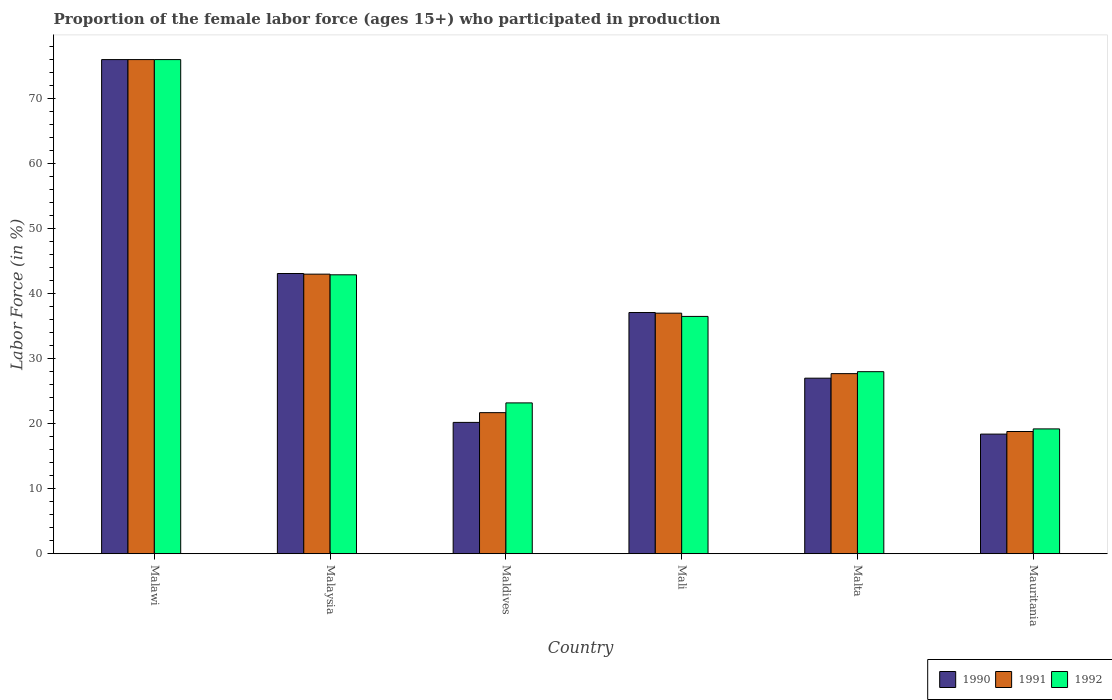How many different coloured bars are there?
Your response must be concise. 3. Are the number of bars per tick equal to the number of legend labels?
Give a very brief answer. Yes. Are the number of bars on each tick of the X-axis equal?
Your answer should be compact. Yes. How many bars are there on the 4th tick from the left?
Offer a terse response. 3. How many bars are there on the 3rd tick from the right?
Provide a succinct answer. 3. What is the label of the 6th group of bars from the left?
Ensure brevity in your answer.  Mauritania. What is the proportion of the female labor force who participated in production in 1992 in Malaysia?
Your response must be concise. 42.9. Across all countries, what is the minimum proportion of the female labor force who participated in production in 1991?
Your answer should be compact. 18.8. In which country was the proportion of the female labor force who participated in production in 1990 maximum?
Your answer should be compact. Malawi. In which country was the proportion of the female labor force who participated in production in 1991 minimum?
Give a very brief answer. Mauritania. What is the total proportion of the female labor force who participated in production in 1992 in the graph?
Give a very brief answer. 225.8. What is the difference between the proportion of the female labor force who participated in production in 1992 in Malawi and that in Mauritania?
Your answer should be very brief. 56.8. What is the difference between the proportion of the female labor force who participated in production in 1991 in Mali and the proportion of the female labor force who participated in production in 1992 in Malta?
Offer a very short reply. 9. What is the average proportion of the female labor force who participated in production in 1992 per country?
Offer a very short reply. 37.63. What is the difference between the proportion of the female labor force who participated in production of/in 1991 and proportion of the female labor force who participated in production of/in 1990 in Malaysia?
Your answer should be very brief. -0.1. In how many countries, is the proportion of the female labor force who participated in production in 1992 greater than 20 %?
Provide a succinct answer. 5. What is the ratio of the proportion of the female labor force who participated in production in 1991 in Mali to that in Malta?
Give a very brief answer. 1.34. Is the proportion of the female labor force who participated in production in 1991 in Malawi less than that in Malaysia?
Your answer should be very brief. No. Is the difference between the proportion of the female labor force who participated in production in 1991 in Malta and Mauritania greater than the difference between the proportion of the female labor force who participated in production in 1990 in Malta and Mauritania?
Offer a terse response. Yes. What is the difference between the highest and the second highest proportion of the female labor force who participated in production in 1992?
Your answer should be compact. -33.1. What is the difference between the highest and the lowest proportion of the female labor force who participated in production in 1992?
Provide a succinct answer. 56.8. Is the sum of the proportion of the female labor force who participated in production in 1991 in Malawi and Mali greater than the maximum proportion of the female labor force who participated in production in 1990 across all countries?
Make the answer very short. Yes. What does the 1st bar from the right in Malawi represents?
Keep it short and to the point. 1992. Are all the bars in the graph horizontal?
Your response must be concise. No. How many countries are there in the graph?
Provide a short and direct response. 6. Does the graph contain grids?
Your answer should be very brief. No. How are the legend labels stacked?
Offer a terse response. Horizontal. What is the title of the graph?
Your response must be concise. Proportion of the female labor force (ages 15+) who participated in production. Does "1999" appear as one of the legend labels in the graph?
Your response must be concise. No. What is the label or title of the Y-axis?
Provide a succinct answer. Labor Force (in %). What is the Labor Force (in %) of 1990 in Malawi?
Offer a very short reply. 76. What is the Labor Force (in %) in 1990 in Malaysia?
Provide a short and direct response. 43.1. What is the Labor Force (in %) of 1992 in Malaysia?
Your answer should be compact. 42.9. What is the Labor Force (in %) in 1990 in Maldives?
Keep it short and to the point. 20.2. What is the Labor Force (in %) of 1991 in Maldives?
Make the answer very short. 21.7. What is the Labor Force (in %) of 1992 in Maldives?
Give a very brief answer. 23.2. What is the Labor Force (in %) in 1990 in Mali?
Give a very brief answer. 37.1. What is the Labor Force (in %) of 1991 in Mali?
Make the answer very short. 37. What is the Labor Force (in %) of 1992 in Mali?
Offer a very short reply. 36.5. What is the Labor Force (in %) in 1990 in Malta?
Your answer should be compact. 27. What is the Labor Force (in %) in 1991 in Malta?
Ensure brevity in your answer.  27.7. What is the Labor Force (in %) in 1992 in Malta?
Offer a terse response. 28. What is the Labor Force (in %) of 1990 in Mauritania?
Keep it short and to the point. 18.4. What is the Labor Force (in %) in 1991 in Mauritania?
Your answer should be compact. 18.8. What is the Labor Force (in %) in 1992 in Mauritania?
Provide a short and direct response. 19.2. Across all countries, what is the maximum Labor Force (in %) of 1991?
Make the answer very short. 76. Across all countries, what is the maximum Labor Force (in %) in 1992?
Give a very brief answer. 76. Across all countries, what is the minimum Labor Force (in %) in 1990?
Keep it short and to the point. 18.4. Across all countries, what is the minimum Labor Force (in %) in 1991?
Offer a very short reply. 18.8. Across all countries, what is the minimum Labor Force (in %) in 1992?
Make the answer very short. 19.2. What is the total Labor Force (in %) of 1990 in the graph?
Make the answer very short. 221.8. What is the total Labor Force (in %) of 1991 in the graph?
Provide a succinct answer. 224.2. What is the total Labor Force (in %) in 1992 in the graph?
Ensure brevity in your answer.  225.8. What is the difference between the Labor Force (in %) in 1990 in Malawi and that in Malaysia?
Offer a very short reply. 32.9. What is the difference between the Labor Force (in %) in 1991 in Malawi and that in Malaysia?
Provide a short and direct response. 33. What is the difference between the Labor Force (in %) of 1992 in Malawi and that in Malaysia?
Offer a terse response. 33.1. What is the difference between the Labor Force (in %) in 1990 in Malawi and that in Maldives?
Provide a succinct answer. 55.8. What is the difference between the Labor Force (in %) of 1991 in Malawi and that in Maldives?
Keep it short and to the point. 54.3. What is the difference between the Labor Force (in %) of 1992 in Malawi and that in Maldives?
Provide a short and direct response. 52.8. What is the difference between the Labor Force (in %) in 1990 in Malawi and that in Mali?
Your answer should be compact. 38.9. What is the difference between the Labor Force (in %) of 1991 in Malawi and that in Mali?
Give a very brief answer. 39. What is the difference between the Labor Force (in %) of 1992 in Malawi and that in Mali?
Your response must be concise. 39.5. What is the difference between the Labor Force (in %) in 1990 in Malawi and that in Malta?
Provide a short and direct response. 49. What is the difference between the Labor Force (in %) in 1991 in Malawi and that in Malta?
Give a very brief answer. 48.3. What is the difference between the Labor Force (in %) in 1990 in Malawi and that in Mauritania?
Give a very brief answer. 57.6. What is the difference between the Labor Force (in %) of 1991 in Malawi and that in Mauritania?
Keep it short and to the point. 57.2. What is the difference between the Labor Force (in %) of 1992 in Malawi and that in Mauritania?
Offer a very short reply. 56.8. What is the difference between the Labor Force (in %) in 1990 in Malaysia and that in Maldives?
Offer a very short reply. 22.9. What is the difference between the Labor Force (in %) in 1991 in Malaysia and that in Maldives?
Give a very brief answer. 21.3. What is the difference between the Labor Force (in %) of 1992 in Malaysia and that in Maldives?
Give a very brief answer. 19.7. What is the difference between the Labor Force (in %) of 1990 in Malaysia and that in Malta?
Your response must be concise. 16.1. What is the difference between the Labor Force (in %) in 1991 in Malaysia and that in Malta?
Provide a short and direct response. 15.3. What is the difference between the Labor Force (in %) of 1992 in Malaysia and that in Malta?
Give a very brief answer. 14.9. What is the difference between the Labor Force (in %) in 1990 in Malaysia and that in Mauritania?
Your answer should be very brief. 24.7. What is the difference between the Labor Force (in %) in 1991 in Malaysia and that in Mauritania?
Your response must be concise. 24.2. What is the difference between the Labor Force (in %) of 1992 in Malaysia and that in Mauritania?
Provide a succinct answer. 23.7. What is the difference between the Labor Force (in %) of 1990 in Maldives and that in Mali?
Provide a succinct answer. -16.9. What is the difference between the Labor Force (in %) of 1991 in Maldives and that in Mali?
Offer a terse response. -15.3. What is the difference between the Labor Force (in %) of 1990 in Maldives and that in Malta?
Keep it short and to the point. -6.8. What is the difference between the Labor Force (in %) in 1990 in Mali and that in Malta?
Ensure brevity in your answer.  10.1. What is the difference between the Labor Force (in %) of 1990 in Malta and that in Mauritania?
Your response must be concise. 8.6. What is the difference between the Labor Force (in %) of 1990 in Malawi and the Labor Force (in %) of 1991 in Malaysia?
Offer a very short reply. 33. What is the difference between the Labor Force (in %) of 1990 in Malawi and the Labor Force (in %) of 1992 in Malaysia?
Your answer should be compact. 33.1. What is the difference between the Labor Force (in %) in 1991 in Malawi and the Labor Force (in %) in 1992 in Malaysia?
Provide a succinct answer. 33.1. What is the difference between the Labor Force (in %) of 1990 in Malawi and the Labor Force (in %) of 1991 in Maldives?
Give a very brief answer. 54.3. What is the difference between the Labor Force (in %) in 1990 in Malawi and the Labor Force (in %) in 1992 in Maldives?
Provide a succinct answer. 52.8. What is the difference between the Labor Force (in %) of 1991 in Malawi and the Labor Force (in %) of 1992 in Maldives?
Ensure brevity in your answer.  52.8. What is the difference between the Labor Force (in %) in 1990 in Malawi and the Labor Force (in %) in 1992 in Mali?
Provide a short and direct response. 39.5. What is the difference between the Labor Force (in %) of 1991 in Malawi and the Labor Force (in %) of 1992 in Mali?
Your answer should be very brief. 39.5. What is the difference between the Labor Force (in %) of 1990 in Malawi and the Labor Force (in %) of 1991 in Malta?
Provide a short and direct response. 48.3. What is the difference between the Labor Force (in %) in 1991 in Malawi and the Labor Force (in %) in 1992 in Malta?
Your answer should be very brief. 48. What is the difference between the Labor Force (in %) of 1990 in Malawi and the Labor Force (in %) of 1991 in Mauritania?
Provide a succinct answer. 57.2. What is the difference between the Labor Force (in %) in 1990 in Malawi and the Labor Force (in %) in 1992 in Mauritania?
Your answer should be compact. 56.8. What is the difference between the Labor Force (in %) of 1991 in Malawi and the Labor Force (in %) of 1992 in Mauritania?
Provide a short and direct response. 56.8. What is the difference between the Labor Force (in %) in 1990 in Malaysia and the Labor Force (in %) in 1991 in Maldives?
Ensure brevity in your answer.  21.4. What is the difference between the Labor Force (in %) in 1991 in Malaysia and the Labor Force (in %) in 1992 in Maldives?
Offer a very short reply. 19.8. What is the difference between the Labor Force (in %) in 1990 in Malaysia and the Labor Force (in %) in 1991 in Mali?
Provide a short and direct response. 6.1. What is the difference between the Labor Force (in %) of 1990 in Malaysia and the Labor Force (in %) of 1992 in Mali?
Keep it short and to the point. 6.6. What is the difference between the Labor Force (in %) of 1990 in Malaysia and the Labor Force (in %) of 1991 in Malta?
Ensure brevity in your answer.  15.4. What is the difference between the Labor Force (in %) in 1990 in Malaysia and the Labor Force (in %) in 1992 in Malta?
Offer a very short reply. 15.1. What is the difference between the Labor Force (in %) of 1990 in Malaysia and the Labor Force (in %) of 1991 in Mauritania?
Make the answer very short. 24.3. What is the difference between the Labor Force (in %) in 1990 in Malaysia and the Labor Force (in %) in 1992 in Mauritania?
Your answer should be compact. 23.9. What is the difference between the Labor Force (in %) in 1991 in Malaysia and the Labor Force (in %) in 1992 in Mauritania?
Offer a terse response. 23.8. What is the difference between the Labor Force (in %) of 1990 in Maldives and the Labor Force (in %) of 1991 in Mali?
Provide a succinct answer. -16.8. What is the difference between the Labor Force (in %) in 1990 in Maldives and the Labor Force (in %) in 1992 in Mali?
Your answer should be very brief. -16.3. What is the difference between the Labor Force (in %) of 1991 in Maldives and the Labor Force (in %) of 1992 in Mali?
Provide a short and direct response. -14.8. What is the difference between the Labor Force (in %) in 1991 in Maldives and the Labor Force (in %) in 1992 in Malta?
Offer a terse response. -6.3. What is the difference between the Labor Force (in %) in 1990 in Maldives and the Labor Force (in %) in 1991 in Mauritania?
Keep it short and to the point. 1.4. What is the difference between the Labor Force (in %) of 1990 in Maldives and the Labor Force (in %) of 1992 in Mauritania?
Give a very brief answer. 1. What is the difference between the Labor Force (in %) in 1990 in Mali and the Labor Force (in %) in 1991 in Malta?
Your response must be concise. 9.4. What is the difference between the Labor Force (in %) of 1991 in Mali and the Labor Force (in %) of 1992 in Malta?
Offer a very short reply. 9. What is the difference between the Labor Force (in %) of 1990 in Mali and the Labor Force (in %) of 1991 in Mauritania?
Give a very brief answer. 18.3. What is the difference between the Labor Force (in %) in 1990 in Mali and the Labor Force (in %) in 1992 in Mauritania?
Provide a succinct answer. 17.9. What is the average Labor Force (in %) in 1990 per country?
Ensure brevity in your answer.  36.97. What is the average Labor Force (in %) of 1991 per country?
Ensure brevity in your answer.  37.37. What is the average Labor Force (in %) in 1992 per country?
Offer a terse response. 37.63. What is the difference between the Labor Force (in %) of 1990 and Labor Force (in %) of 1991 in Malawi?
Make the answer very short. 0. What is the difference between the Labor Force (in %) of 1990 and Labor Force (in %) of 1992 in Malawi?
Offer a terse response. 0. What is the difference between the Labor Force (in %) in 1991 and Labor Force (in %) in 1992 in Malawi?
Your response must be concise. 0. What is the difference between the Labor Force (in %) in 1990 and Labor Force (in %) in 1991 in Malaysia?
Your response must be concise. 0.1. What is the difference between the Labor Force (in %) of 1990 and Labor Force (in %) of 1992 in Malaysia?
Keep it short and to the point. 0.2. What is the difference between the Labor Force (in %) in 1990 and Labor Force (in %) in 1992 in Maldives?
Your answer should be very brief. -3. What is the difference between the Labor Force (in %) of 1990 and Labor Force (in %) of 1992 in Mali?
Make the answer very short. 0.6. What is the difference between the Labor Force (in %) of 1990 and Labor Force (in %) of 1991 in Malta?
Provide a succinct answer. -0.7. What is the difference between the Labor Force (in %) in 1990 and Labor Force (in %) in 1992 in Malta?
Your answer should be very brief. -1. What is the difference between the Labor Force (in %) in 1991 and Labor Force (in %) in 1992 in Malta?
Your response must be concise. -0.3. What is the difference between the Labor Force (in %) in 1990 and Labor Force (in %) in 1991 in Mauritania?
Give a very brief answer. -0.4. What is the difference between the Labor Force (in %) in 1991 and Labor Force (in %) in 1992 in Mauritania?
Offer a terse response. -0.4. What is the ratio of the Labor Force (in %) of 1990 in Malawi to that in Malaysia?
Your response must be concise. 1.76. What is the ratio of the Labor Force (in %) in 1991 in Malawi to that in Malaysia?
Ensure brevity in your answer.  1.77. What is the ratio of the Labor Force (in %) in 1992 in Malawi to that in Malaysia?
Ensure brevity in your answer.  1.77. What is the ratio of the Labor Force (in %) in 1990 in Malawi to that in Maldives?
Make the answer very short. 3.76. What is the ratio of the Labor Force (in %) in 1991 in Malawi to that in Maldives?
Your response must be concise. 3.5. What is the ratio of the Labor Force (in %) of 1992 in Malawi to that in Maldives?
Provide a succinct answer. 3.28. What is the ratio of the Labor Force (in %) in 1990 in Malawi to that in Mali?
Ensure brevity in your answer.  2.05. What is the ratio of the Labor Force (in %) of 1991 in Malawi to that in Mali?
Provide a succinct answer. 2.05. What is the ratio of the Labor Force (in %) in 1992 in Malawi to that in Mali?
Ensure brevity in your answer.  2.08. What is the ratio of the Labor Force (in %) in 1990 in Malawi to that in Malta?
Ensure brevity in your answer.  2.81. What is the ratio of the Labor Force (in %) in 1991 in Malawi to that in Malta?
Ensure brevity in your answer.  2.74. What is the ratio of the Labor Force (in %) of 1992 in Malawi to that in Malta?
Ensure brevity in your answer.  2.71. What is the ratio of the Labor Force (in %) of 1990 in Malawi to that in Mauritania?
Offer a very short reply. 4.13. What is the ratio of the Labor Force (in %) in 1991 in Malawi to that in Mauritania?
Keep it short and to the point. 4.04. What is the ratio of the Labor Force (in %) in 1992 in Malawi to that in Mauritania?
Your answer should be very brief. 3.96. What is the ratio of the Labor Force (in %) in 1990 in Malaysia to that in Maldives?
Offer a terse response. 2.13. What is the ratio of the Labor Force (in %) of 1991 in Malaysia to that in Maldives?
Ensure brevity in your answer.  1.98. What is the ratio of the Labor Force (in %) in 1992 in Malaysia to that in Maldives?
Make the answer very short. 1.85. What is the ratio of the Labor Force (in %) of 1990 in Malaysia to that in Mali?
Provide a short and direct response. 1.16. What is the ratio of the Labor Force (in %) in 1991 in Malaysia to that in Mali?
Your answer should be very brief. 1.16. What is the ratio of the Labor Force (in %) of 1992 in Malaysia to that in Mali?
Provide a succinct answer. 1.18. What is the ratio of the Labor Force (in %) in 1990 in Malaysia to that in Malta?
Keep it short and to the point. 1.6. What is the ratio of the Labor Force (in %) of 1991 in Malaysia to that in Malta?
Provide a short and direct response. 1.55. What is the ratio of the Labor Force (in %) in 1992 in Malaysia to that in Malta?
Provide a short and direct response. 1.53. What is the ratio of the Labor Force (in %) of 1990 in Malaysia to that in Mauritania?
Provide a succinct answer. 2.34. What is the ratio of the Labor Force (in %) of 1991 in Malaysia to that in Mauritania?
Provide a short and direct response. 2.29. What is the ratio of the Labor Force (in %) in 1992 in Malaysia to that in Mauritania?
Make the answer very short. 2.23. What is the ratio of the Labor Force (in %) of 1990 in Maldives to that in Mali?
Your answer should be very brief. 0.54. What is the ratio of the Labor Force (in %) of 1991 in Maldives to that in Mali?
Provide a succinct answer. 0.59. What is the ratio of the Labor Force (in %) in 1992 in Maldives to that in Mali?
Keep it short and to the point. 0.64. What is the ratio of the Labor Force (in %) of 1990 in Maldives to that in Malta?
Offer a terse response. 0.75. What is the ratio of the Labor Force (in %) of 1991 in Maldives to that in Malta?
Offer a terse response. 0.78. What is the ratio of the Labor Force (in %) of 1992 in Maldives to that in Malta?
Keep it short and to the point. 0.83. What is the ratio of the Labor Force (in %) in 1990 in Maldives to that in Mauritania?
Make the answer very short. 1.1. What is the ratio of the Labor Force (in %) of 1991 in Maldives to that in Mauritania?
Offer a terse response. 1.15. What is the ratio of the Labor Force (in %) in 1992 in Maldives to that in Mauritania?
Make the answer very short. 1.21. What is the ratio of the Labor Force (in %) in 1990 in Mali to that in Malta?
Provide a succinct answer. 1.37. What is the ratio of the Labor Force (in %) of 1991 in Mali to that in Malta?
Keep it short and to the point. 1.34. What is the ratio of the Labor Force (in %) of 1992 in Mali to that in Malta?
Your answer should be compact. 1.3. What is the ratio of the Labor Force (in %) of 1990 in Mali to that in Mauritania?
Make the answer very short. 2.02. What is the ratio of the Labor Force (in %) of 1991 in Mali to that in Mauritania?
Give a very brief answer. 1.97. What is the ratio of the Labor Force (in %) of 1992 in Mali to that in Mauritania?
Your response must be concise. 1.9. What is the ratio of the Labor Force (in %) of 1990 in Malta to that in Mauritania?
Provide a short and direct response. 1.47. What is the ratio of the Labor Force (in %) of 1991 in Malta to that in Mauritania?
Make the answer very short. 1.47. What is the ratio of the Labor Force (in %) of 1992 in Malta to that in Mauritania?
Offer a very short reply. 1.46. What is the difference between the highest and the second highest Labor Force (in %) of 1990?
Your answer should be compact. 32.9. What is the difference between the highest and the second highest Labor Force (in %) of 1991?
Your response must be concise. 33. What is the difference between the highest and the second highest Labor Force (in %) of 1992?
Give a very brief answer. 33.1. What is the difference between the highest and the lowest Labor Force (in %) of 1990?
Offer a terse response. 57.6. What is the difference between the highest and the lowest Labor Force (in %) in 1991?
Offer a terse response. 57.2. What is the difference between the highest and the lowest Labor Force (in %) of 1992?
Keep it short and to the point. 56.8. 